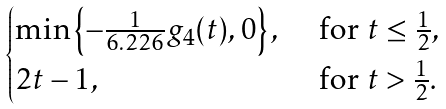<formula> <loc_0><loc_0><loc_500><loc_500>\begin{cases} \min \left \{ - \frac { 1 } { 6 . 2 2 6 } g _ { 4 } ( t ) , 0 \right \} , & \text { for } t \leq \frac { 1 } { 2 } , \\ 2 t - 1 , & \text { for } t > \frac { 1 } { 2 } . \end{cases}</formula> 